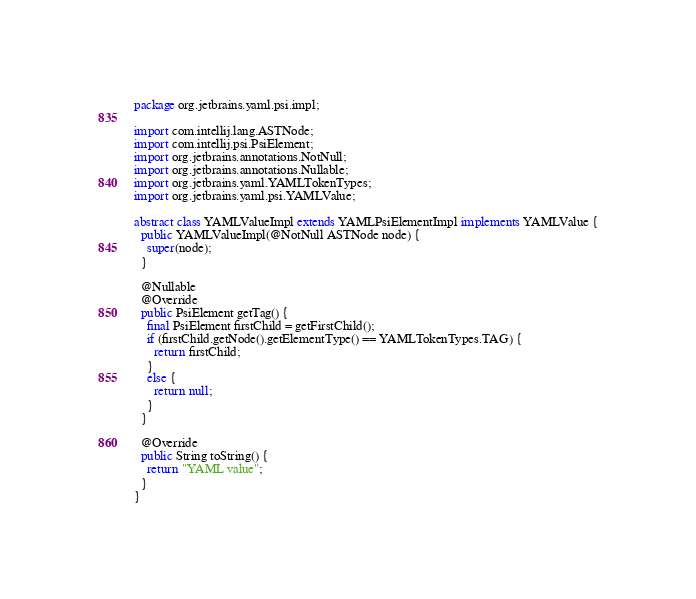Convert code to text. <code><loc_0><loc_0><loc_500><loc_500><_Java_>package org.jetbrains.yaml.psi.impl;

import com.intellij.lang.ASTNode;
import com.intellij.psi.PsiElement;
import org.jetbrains.annotations.NotNull;
import org.jetbrains.annotations.Nullable;
import org.jetbrains.yaml.YAMLTokenTypes;
import org.jetbrains.yaml.psi.YAMLValue;

abstract class YAMLValueImpl extends YAMLPsiElementImpl implements YAMLValue {
  public YAMLValueImpl(@NotNull ASTNode node) {
    super(node);
  }

  @Nullable
  @Override
  public PsiElement getTag() {
    final PsiElement firstChild = getFirstChild();
    if (firstChild.getNode().getElementType() == YAMLTokenTypes.TAG) {
      return firstChild;
    }
    else {
      return null;
    }
  }

  @Override
  public String toString() {
    return "YAML value";
  }
}
</code> 